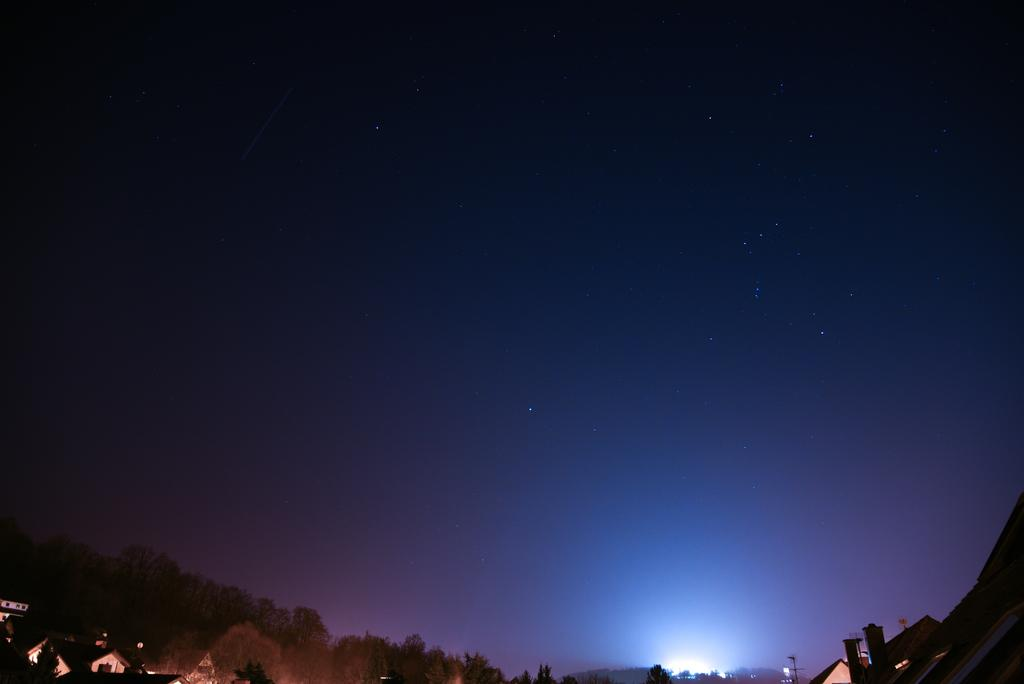What is the lighting condition in the image? The image was taken in the dark. What can be seen at the bottom of the image? There are buildings, trees, and lights visible at the bottom of the image. What is visible in the sky at the top of the image? The sky is visible at the top of the image, and stars are visible in it. What type of treatment is being administered to the pollution in the image? There is no mention of pollution in the image, so it is not possible to discuss any treatment being administered. 